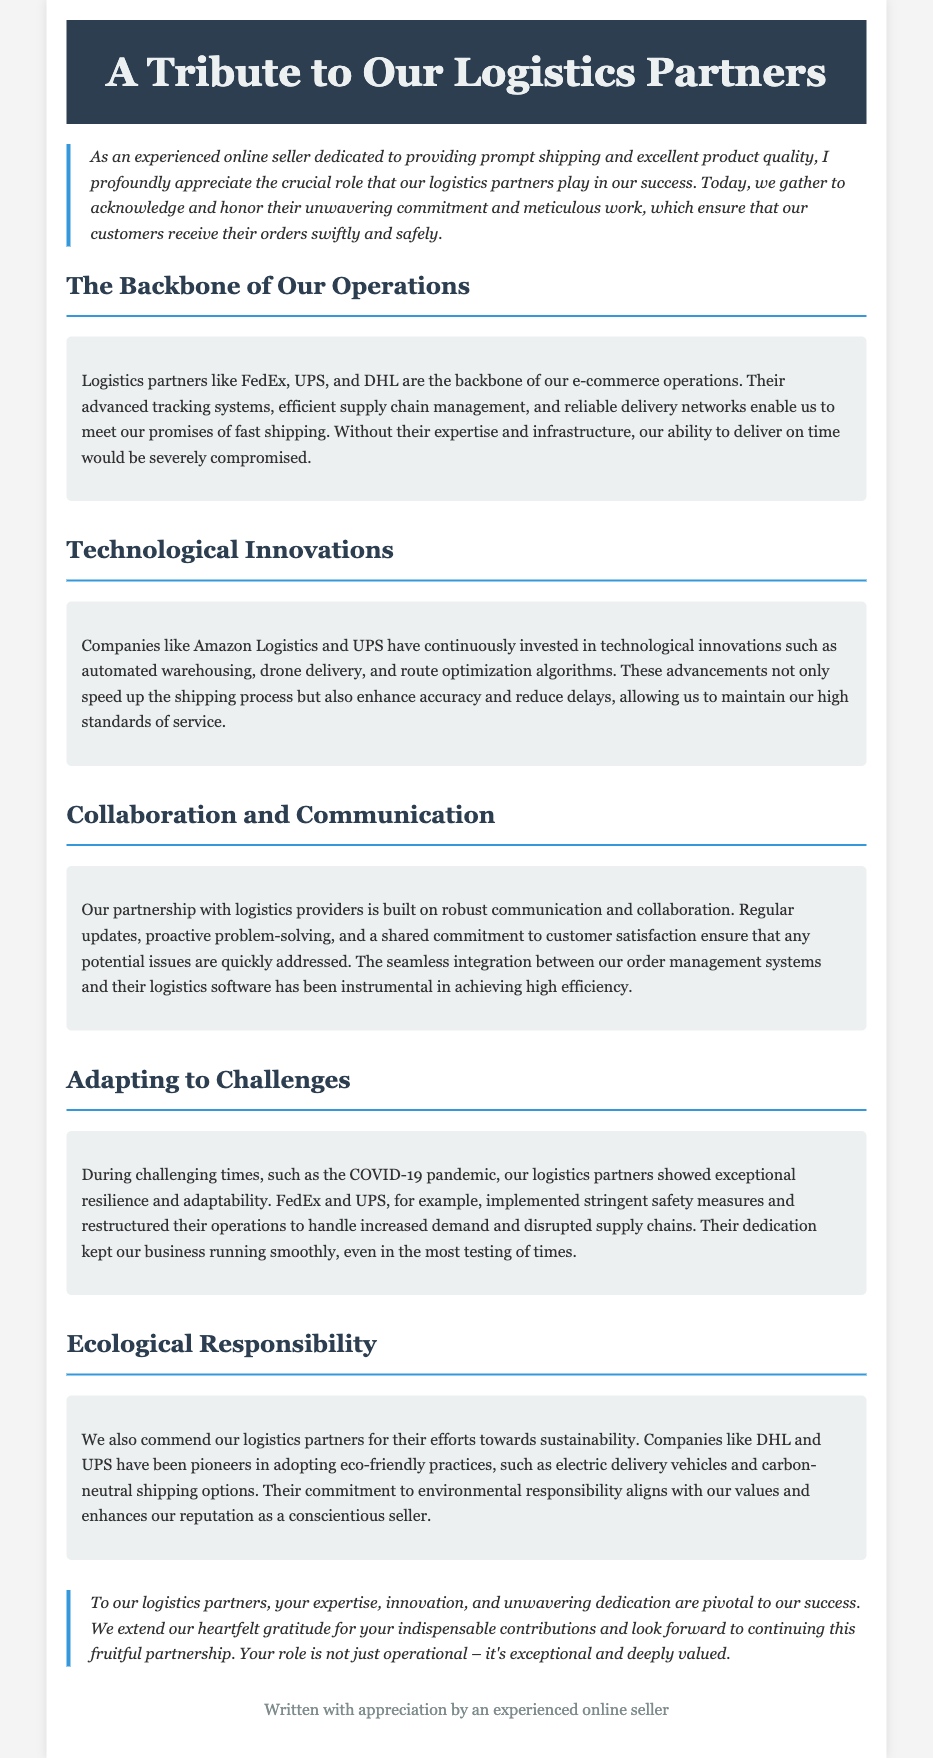What are the names of two logistics partners mentioned? The document lists FedEx and UPS as examples of logistics partners, highlighting their critical roles in the e-commerce operations.
Answer: FedEx, UPS What is a key technological innovation mentioned? The eulogy mentions automated warehousing as a technological innovation that enhances the shipping process and logistics efficiency.
Answer: Automated warehousing What organization showed resilience during the COVID-19 pandemic? FedEx and UPS are specifically noted for their exceptional resilience and adaptability during the COVID-19 pandemic, reshaping their operations.
Answer: FedEx and UPS What does the eulogy commend logistics partners for regarding sustainability? The document praises logistics partners like DHL and UPS for adopting eco-friendly practices and initiatives, promoting environmental responsibility.
Answer: Eco-friendly practices What is described as instrumental to achieving high efficiency in logistics? The seamless integration between the order management systems and the logistics software is highlighted as a major factor for achieving high efficiency.
Answer: Integration between systems What is the overall tone of the document? The document conveys a tone of gratitude and appreciation for logistics partners, emphasizing their indispensable contributions to business success.
Answer: Gratitude and appreciation How did logistics partners contribute to customer satisfaction? Regular updates and proactive problem-solving with logistics providers are noted as ways that enhance customer satisfaction and service quality.
Answer: Regular updates and proactive problem-solving Which type of delivery vehicles is mentioned in connection with ecological responsibility? The eulogy notes that electric delivery vehicles have been adopted by logistics companies to enhance sustainability practices.
Answer: Electric delivery vehicles 